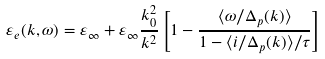<formula> <loc_0><loc_0><loc_500><loc_500>\varepsilon _ { e } ( { k } , \omega ) = \varepsilon _ { \infty } + \varepsilon _ { \infty } \frac { k _ { 0 } ^ { 2 } } { k ^ { 2 } } \left [ 1 - \frac { \langle \omega / \Delta _ { p } ( k ) \rangle } { 1 - \langle i / \Delta _ { p } ( k ) \rangle / \tau } \right ]</formula> 